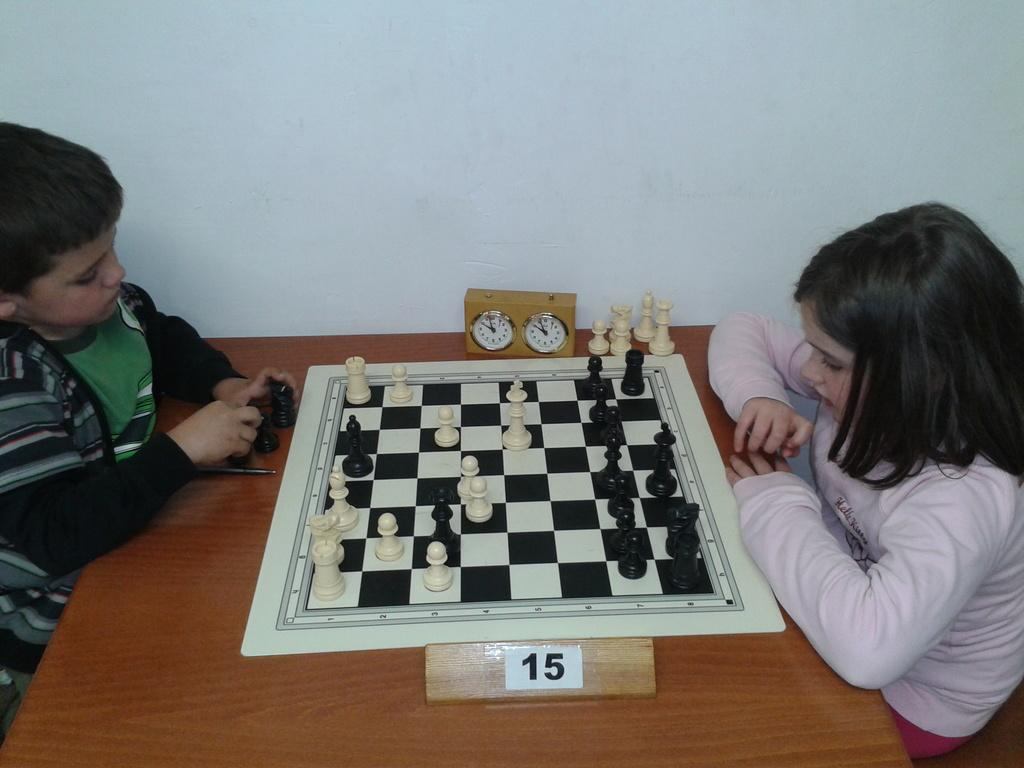How many people are in the image? There are two persons in the image. What are the persons doing in the image? The persons are sitting in chairs and playing a chess board game. What object is present on the table in the image? There is a timer on the table. What type of animal can be seen playing with the chess pieces in the image? There are no animals present in the image; the persons are playing the chess board game. How many squares are on the chess board in the image? The image does not show the entire chess board, so it is impossible to determine the exact number of squares. 